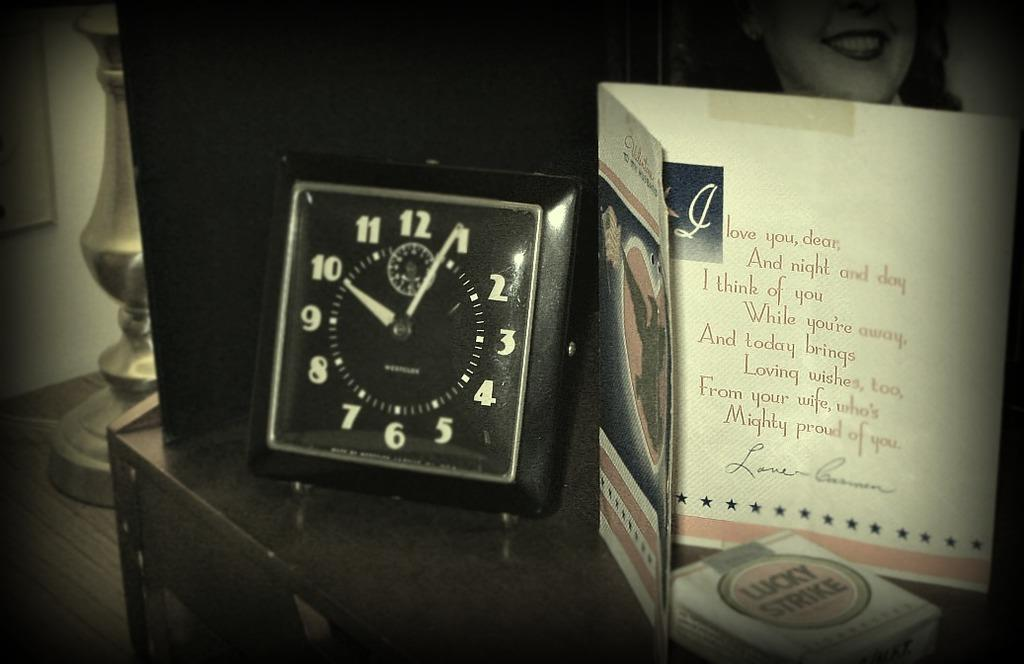<image>
Give a short and clear explanation of the subsequent image. the word love is on the white card next to the clock 